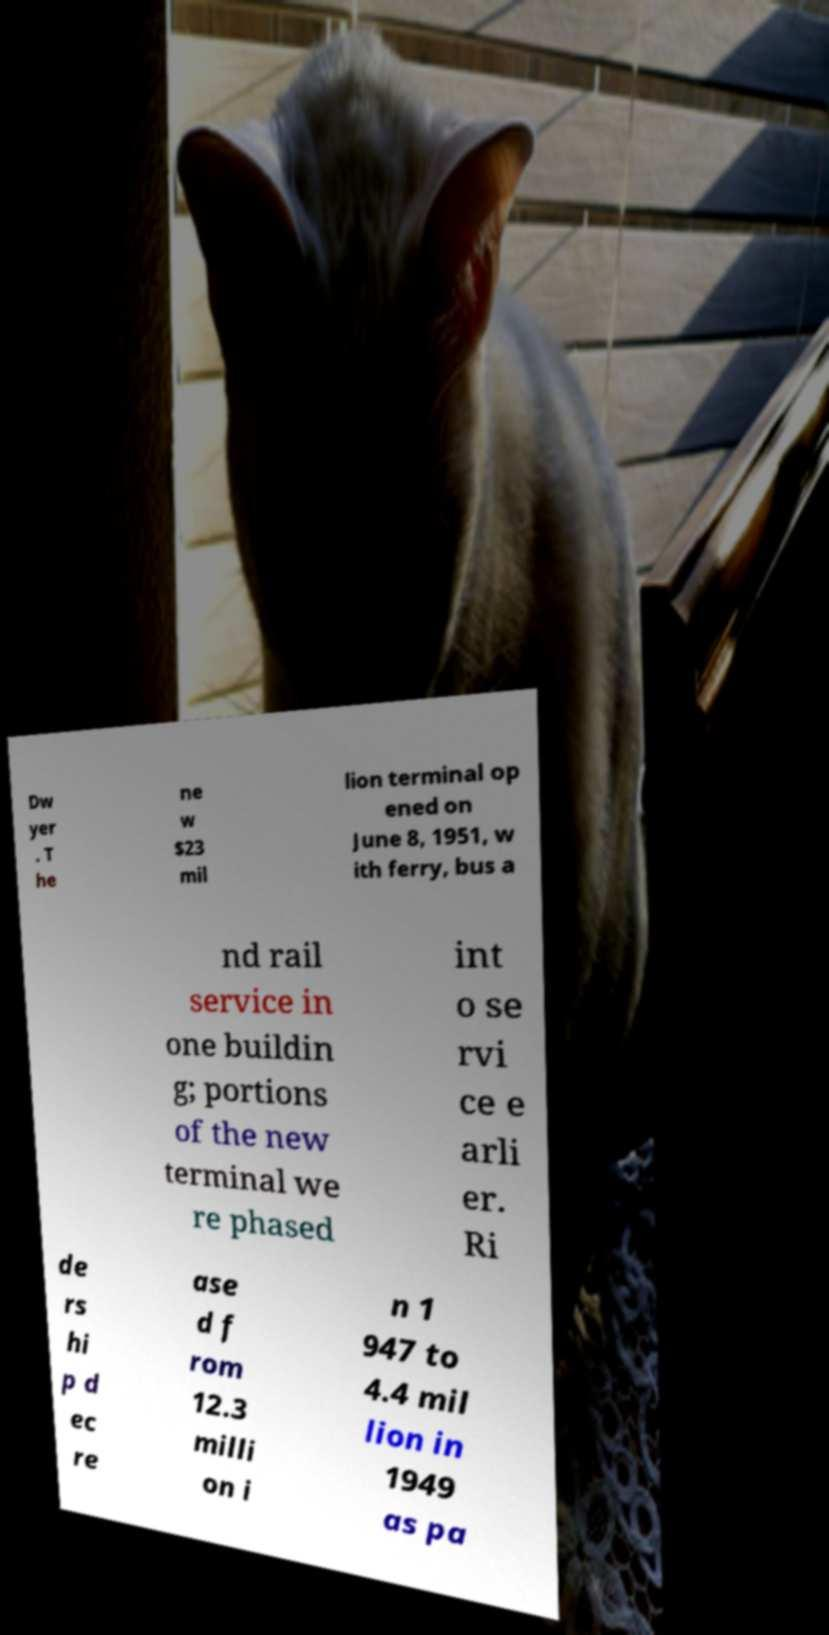Please read and relay the text visible in this image. What does it say? Dw yer . T he ne w $23 mil lion terminal op ened on June 8, 1951, w ith ferry, bus a nd rail service in one buildin g; portions of the new terminal we re phased int o se rvi ce e arli er. Ri de rs hi p d ec re ase d f rom 12.3 milli on i n 1 947 to 4.4 mil lion in 1949 as pa 